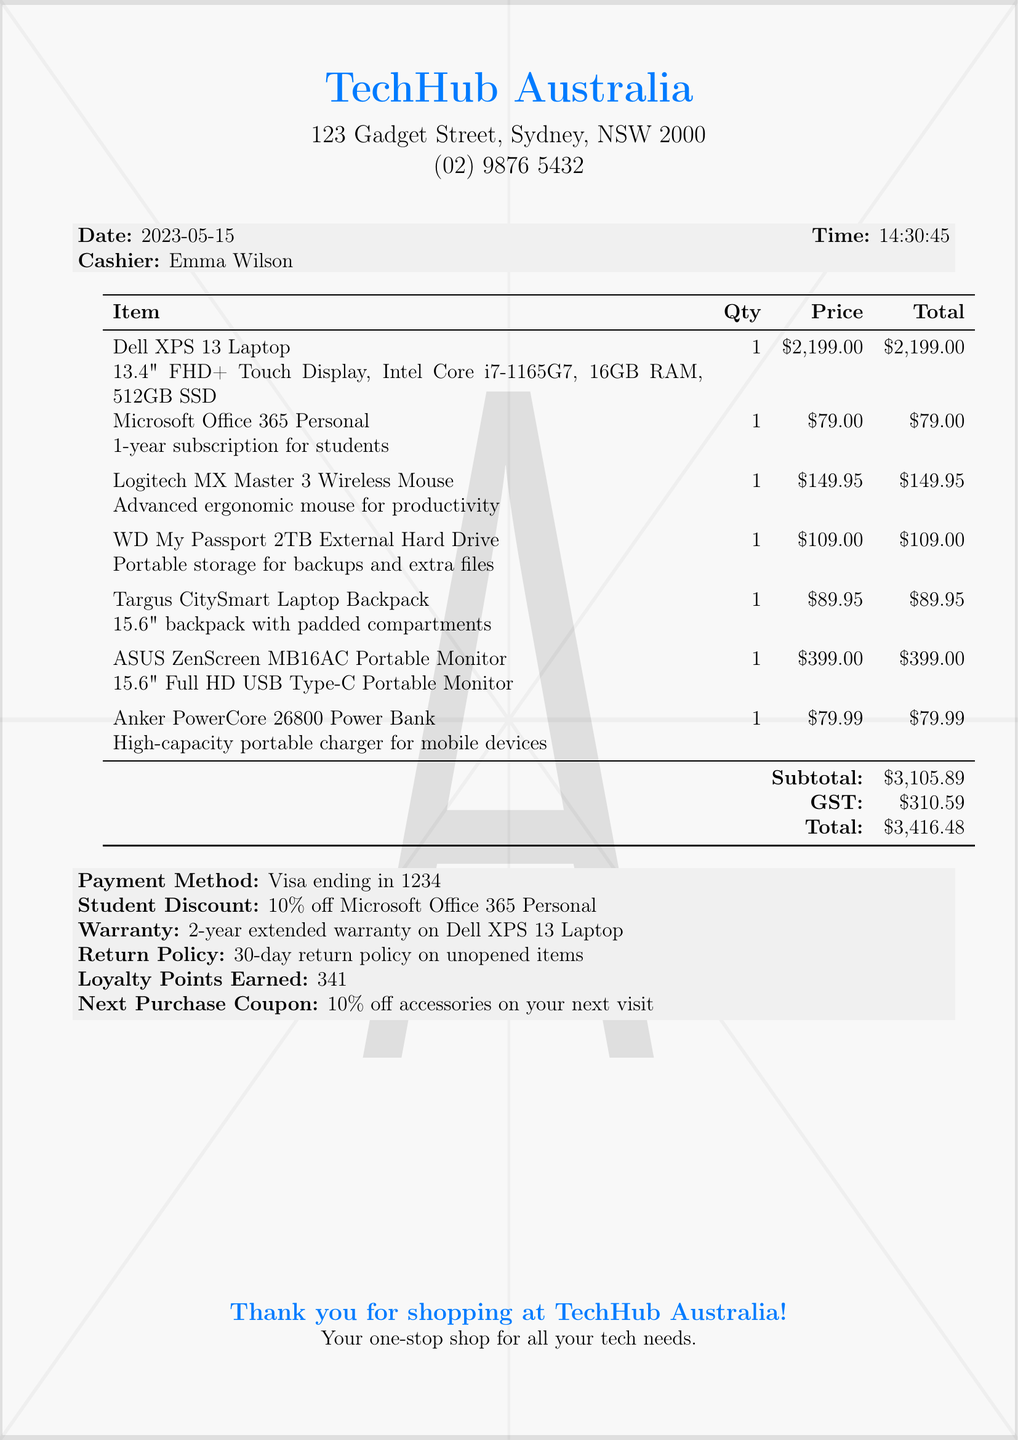What is the name of the store? The name of the store is at the top of the receipt, which displays "TechHub Australia".
Answer: TechHub Australia What is the total amount spent? The total amount spent is listed at the end of the receipt, shown clearly as the total.
Answer: $3,416.48 Who was the cashier? The cashier's name is mentioned in the header section of the receipt as the person who processed the sale.
Answer: Emma Wilson How many loyalty points were earned? The loyalty points earned are stated in the receipt under the additional information section.
Answer: 341 What is the warranty period for the Dell XPS 13 Laptop? The warranty period for the laptop is provided in the additional information, indicating a specific duration of coverage.
Answer: 2-year extended warranty What discount was provided on Microsoft Office 365 Personal? The specific discount for the software is indicated in the receipt, showing the type of offer applied due to student status.
Answer: 10% off What is the return policy mentioned? The return policy is stated in the details at the bottom of the receipt, specifying conditions for returning products.
Answer: 30-day return policy on unopened items Which item has the highest price? By comparing the prices listed under the items, it is clear which one costs the most.
Answer: Dell XPS 13 Laptop What type of payment was used? The method of payment is explicitly stated near the end of the receipt, giving clarity on how the transaction was completed.
Answer: Visa ending in 1234 